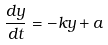<formula> <loc_0><loc_0><loc_500><loc_500>\frac { d y } { d t } = - k y + a</formula> 